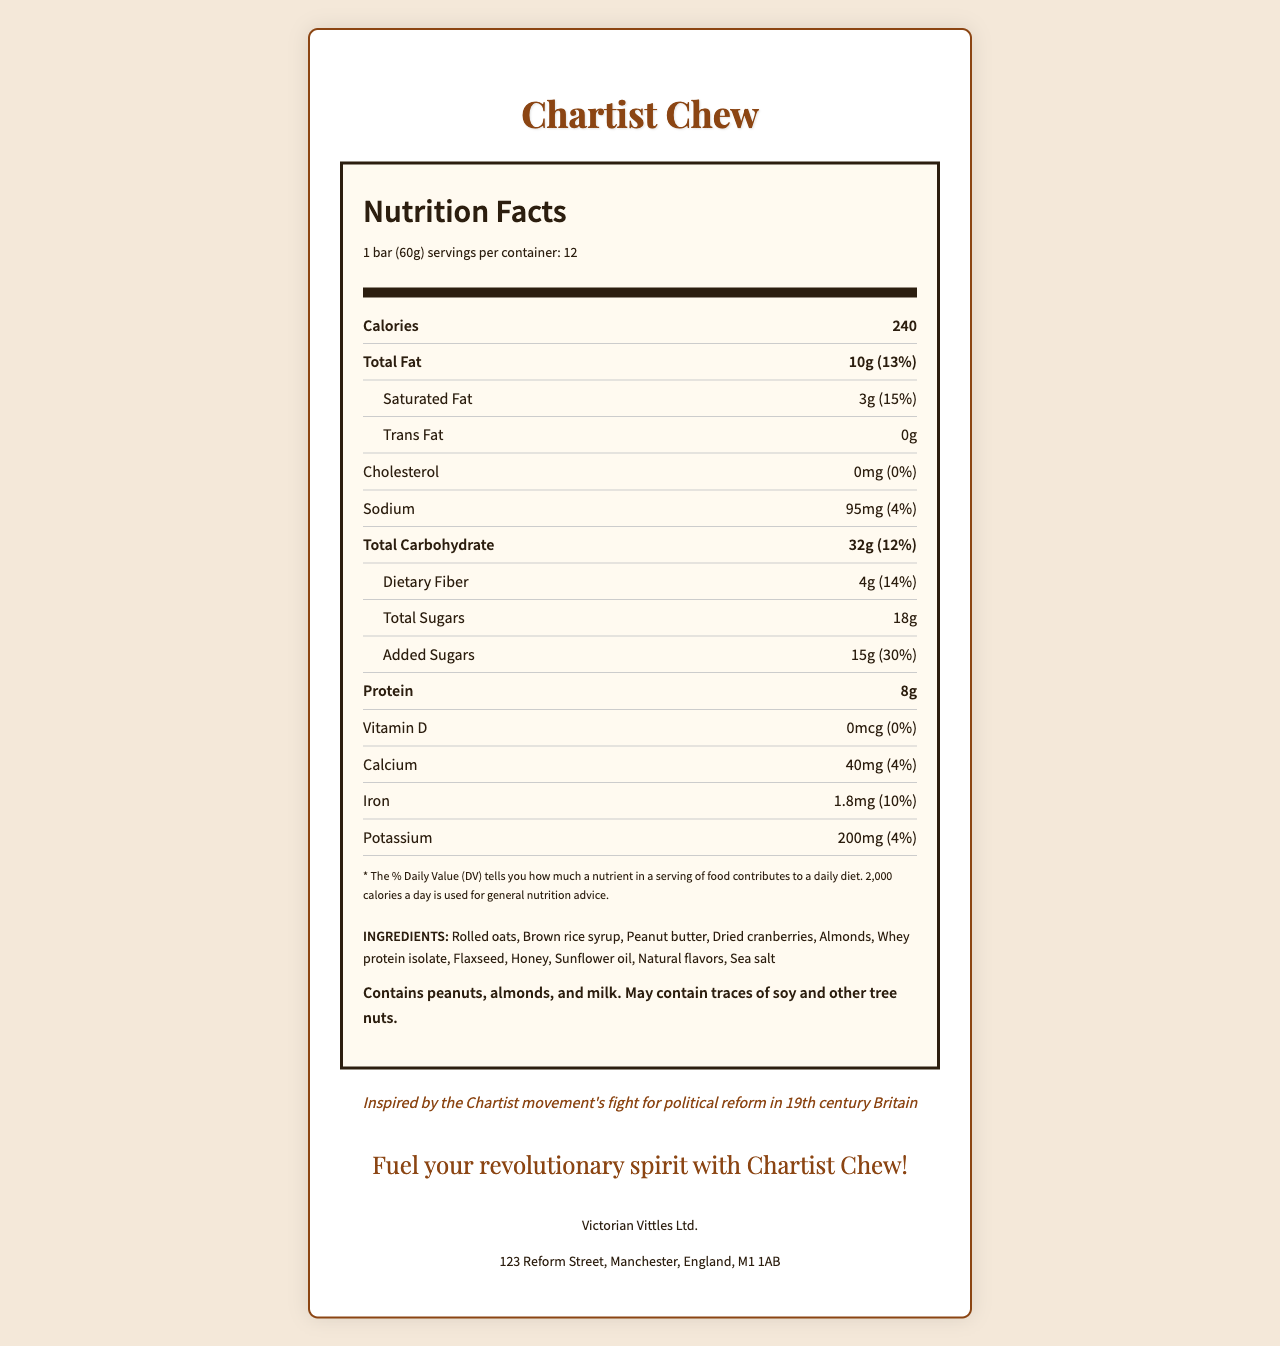what is the serving size for Chartist Chew? The serving size is listed at the top of the Nutrition Facts section as "1 bar (60g)".
Answer: 1 bar (60g) how many servings are there per container? The number of servings per container is mentioned just below the serving size as "servings per container: 12".
Answer: 12 how many calories are in one bar of Chartist Chew? The calories per serving are indicated right next to the header “Calories” as "240".
Answer: 240 what is the total fat content and its daily value percentage? The total fat content is mentioned as "10g", and its contribution to the daily value is shown as "13%".
Answer: 10g, 13% what is the amount of dietary fiber in a single bar? The amount of dietary fiber is listed as "4g" under the "Total Carbohydrate" section.
Answer: 4g what are the three main allergen ingredients in Chartist Chew? The allergen information at the bottom specifies that the product "Contains peanuts, almonds, and milk."
Answer: Peanuts, almonds, and milk does the product contain any cholesterol? The cholesterol section shows "0mg" and "0%" for the daily value, indicating no cholesterol in the product.
Answer: No what percentage of the Daily Value does the added sugars in Chartist Chew contribute? A. 14% B. 20% C. 30% The added sugars section shows "15g" and a daily value percentage of "30%".
Answer: C. 30% how much iron is present in the product? A. 1mg B. 1.5mg C. 1.8mg D. 2mg The iron content is specified as "1.8mg" with a daily value contribution of "10%".
Answer: C. 1.8mg is Chartist Chew suitable for someone with a soy allergy? The allergen information states, "May contain traces of soy," so it's not guaranteed to be free of soy.
Answer: Maybe, it may contain traces of soy describe the main historical inspiration behind Chartist Chew. The document includes a historical note that the product is inspired by the Chartist movement for political reform in 19th-century Britain.
Answer: Inspired by the Chartist movement's fight for political reform in 19th century Britain who manufactures Chartist Chew and where are they located? The manufacturer information at the bottom of the document states "Victorian Vittles Ltd." located at "123 Reform Street, Manchester, England, M1 1AB."
Answer: Victorian Vittles Ltd. in Manchester, England what is the total carbohydrate content per bar? The total carbohydrate content is stated as "32g".
Answer: 32g does the product contain any vitamin D? The vitamin D section shows "0mcg" and "0%" for the daily value.
Answer: No how is Chartist Chew marketed? The marketing tagline at the bottom of the document states, "Fuel your revolutionary spirit with Chartist Chew!"
Answer: As a source of energy for revolutionary spirit with the tagline "Fuel your revolutionary spirit with Chartist Chew!" what are the main ingredients used in Chartist Chew that can be linked to the historical theme? The ingredients list encompasses foods which could have been accessible during the 19th century, fitting the historical theme.
Answer: Rolled oats, brown rice syrup, peanut butter, dried cranberries, almonds, whey protein isolate, flaxseed, honey, sunflower oil, natural flavors, sea salt what percentage of daily sodium intake does one bar of Chartist Chew provide? The sodium content section shows "95mg" and a daily value of "4%".
Answer: 4% what is the approximate weight of the entire container? Given there are 12 bars per container and each bar weighs 60g, the total weight is 12 x 60g = 720g.
Answer: 720g is Chartist Chew free of gluten? The document does not provide enough information to determine if Chartist Chew is gluten-free.
Answer: Not enough information 